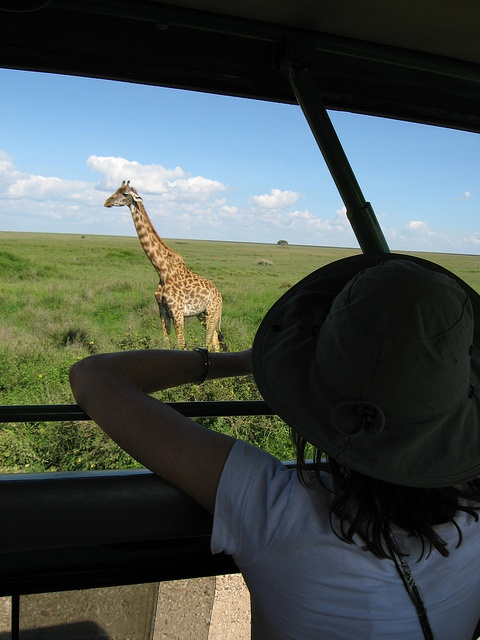Describe the objects in this image and their specific colors. I can see people in black, gray, and darkblue tones and giraffe in black, tan, olive, and gray tones in this image. 